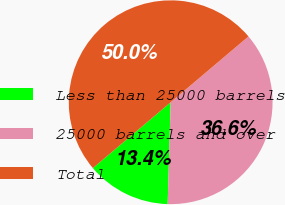Convert chart. <chart><loc_0><loc_0><loc_500><loc_500><pie_chart><fcel>Less than 25000 barrels<fcel>25000 barrels and over<fcel>Total<nl><fcel>13.36%<fcel>36.64%<fcel>50.0%<nl></chart> 